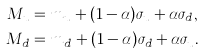Convert formula to latex. <formula><loc_0><loc_0><loc_500><loc_500>M _ { u } & = m _ { u } + ( 1 - \alpha ) \sigma _ { u } + \alpha \sigma _ { d } , \\ M _ { d } & = m _ { d } + ( 1 - \alpha ) \sigma _ { d } + \alpha \sigma _ { u } .</formula> 